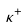Convert formula to latex. <formula><loc_0><loc_0><loc_500><loc_500>\kappa ^ { + }</formula> 